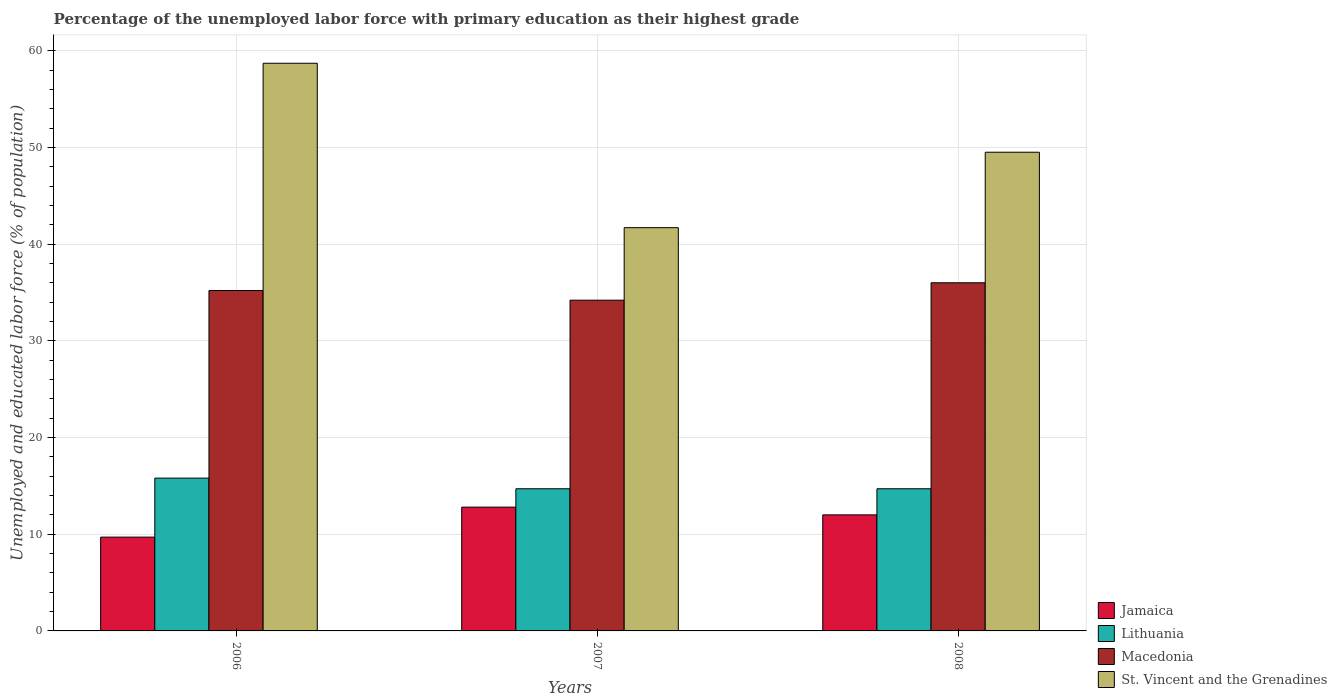Are the number of bars per tick equal to the number of legend labels?
Your response must be concise. Yes. What is the label of the 3rd group of bars from the left?
Ensure brevity in your answer.  2008. Across all years, what is the maximum percentage of the unemployed labor force with primary education in Lithuania?
Give a very brief answer. 15.8. Across all years, what is the minimum percentage of the unemployed labor force with primary education in Lithuania?
Keep it short and to the point. 14.7. What is the total percentage of the unemployed labor force with primary education in Jamaica in the graph?
Keep it short and to the point. 34.5. What is the difference between the percentage of the unemployed labor force with primary education in Lithuania in 2006 and that in 2007?
Give a very brief answer. 1.1. What is the difference between the percentage of the unemployed labor force with primary education in St. Vincent and the Grenadines in 2007 and the percentage of the unemployed labor force with primary education in Jamaica in 2006?
Offer a very short reply. 32. What is the average percentage of the unemployed labor force with primary education in St. Vincent and the Grenadines per year?
Provide a succinct answer. 49.97. In the year 2008, what is the difference between the percentage of the unemployed labor force with primary education in Lithuania and percentage of the unemployed labor force with primary education in St. Vincent and the Grenadines?
Make the answer very short. -34.8. What is the difference between the highest and the second highest percentage of the unemployed labor force with primary education in St. Vincent and the Grenadines?
Provide a succinct answer. 9.2. What is the difference between the highest and the lowest percentage of the unemployed labor force with primary education in Macedonia?
Provide a short and direct response. 1.8. Is the sum of the percentage of the unemployed labor force with primary education in Lithuania in 2007 and 2008 greater than the maximum percentage of the unemployed labor force with primary education in Jamaica across all years?
Your response must be concise. Yes. What does the 4th bar from the left in 2006 represents?
Give a very brief answer. St. Vincent and the Grenadines. What does the 3rd bar from the right in 2006 represents?
Offer a very short reply. Lithuania. What is the difference between two consecutive major ticks on the Y-axis?
Keep it short and to the point. 10. Where does the legend appear in the graph?
Your response must be concise. Bottom right. How many legend labels are there?
Provide a succinct answer. 4. How are the legend labels stacked?
Keep it short and to the point. Vertical. What is the title of the graph?
Offer a terse response. Percentage of the unemployed labor force with primary education as their highest grade. Does "Gabon" appear as one of the legend labels in the graph?
Make the answer very short. No. What is the label or title of the Y-axis?
Keep it short and to the point. Unemployed and educated labor force (% of population). What is the Unemployed and educated labor force (% of population) in Jamaica in 2006?
Your answer should be very brief. 9.7. What is the Unemployed and educated labor force (% of population) in Lithuania in 2006?
Provide a short and direct response. 15.8. What is the Unemployed and educated labor force (% of population) of Macedonia in 2006?
Make the answer very short. 35.2. What is the Unemployed and educated labor force (% of population) of St. Vincent and the Grenadines in 2006?
Ensure brevity in your answer.  58.7. What is the Unemployed and educated labor force (% of population) in Jamaica in 2007?
Your answer should be very brief. 12.8. What is the Unemployed and educated labor force (% of population) in Lithuania in 2007?
Your answer should be very brief. 14.7. What is the Unemployed and educated labor force (% of population) of Macedonia in 2007?
Ensure brevity in your answer.  34.2. What is the Unemployed and educated labor force (% of population) of St. Vincent and the Grenadines in 2007?
Provide a succinct answer. 41.7. What is the Unemployed and educated labor force (% of population) in Jamaica in 2008?
Your answer should be very brief. 12. What is the Unemployed and educated labor force (% of population) of Lithuania in 2008?
Ensure brevity in your answer.  14.7. What is the Unemployed and educated labor force (% of population) of Macedonia in 2008?
Provide a succinct answer. 36. What is the Unemployed and educated labor force (% of population) in St. Vincent and the Grenadines in 2008?
Provide a short and direct response. 49.5. Across all years, what is the maximum Unemployed and educated labor force (% of population) in Jamaica?
Your answer should be compact. 12.8. Across all years, what is the maximum Unemployed and educated labor force (% of population) in Lithuania?
Offer a terse response. 15.8. Across all years, what is the maximum Unemployed and educated labor force (% of population) in St. Vincent and the Grenadines?
Ensure brevity in your answer.  58.7. Across all years, what is the minimum Unemployed and educated labor force (% of population) of Jamaica?
Offer a terse response. 9.7. Across all years, what is the minimum Unemployed and educated labor force (% of population) of Lithuania?
Your answer should be compact. 14.7. Across all years, what is the minimum Unemployed and educated labor force (% of population) in Macedonia?
Ensure brevity in your answer.  34.2. Across all years, what is the minimum Unemployed and educated labor force (% of population) of St. Vincent and the Grenadines?
Your answer should be compact. 41.7. What is the total Unemployed and educated labor force (% of population) of Jamaica in the graph?
Your answer should be compact. 34.5. What is the total Unemployed and educated labor force (% of population) of Lithuania in the graph?
Offer a very short reply. 45.2. What is the total Unemployed and educated labor force (% of population) in Macedonia in the graph?
Provide a succinct answer. 105.4. What is the total Unemployed and educated labor force (% of population) of St. Vincent and the Grenadines in the graph?
Give a very brief answer. 149.9. What is the difference between the Unemployed and educated labor force (% of population) of Macedonia in 2006 and that in 2007?
Your answer should be very brief. 1. What is the difference between the Unemployed and educated labor force (% of population) of Jamaica in 2006 and that in 2008?
Ensure brevity in your answer.  -2.3. What is the difference between the Unemployed and educated labor force (% of population) in Lithuania in 2006 and that in 2008?
Your response must be concise. 1.1. What is the difference between the Unemployed and educated labor force (% of population) of Macedonia in 2006 and that in 2008?
Your response must be concise. -0.8. What is the difference between the Unemployed and educated labor force (% of population) in St. Vincent and the Grenadines in 2006 and that in 2008?
Your answer should be very brief. 9.2. What is the difference between the Unemployed and educated labor force (% of population) of Jamaica in 2007 and that in 2008?
Offer a very short reply. 0.8. What is the difference between the Unemployed and educated labor force (% of population) in Lithuania in 2007 and that in 2008?
Ensure brevity in your answer.  0. What is the difference between the Unemployed and educated labor force (% of population) in St. Vincent and the Grenadines in 2007 and that in 2008?
Give a very brief answer. -7.8. What is the difference between the Unemployed and educated labor force (% of population) in Jamaica in 2006 and the Unemployed and educated labor force (% of population) in Macedonia in 2007?
Your answer should be very brief. -24.5. What is the difference between the Unemployed and educated labor force (% of population) in Jamaica in 2006 and the Unemployed and educated labor force (% of population) in St. Vincent and the Grenadines in 2007?
Keep it short and to the point. -32. What is the difference between the Unemployed and educated labor force (% of population) in Lithuania in 2006 and the Unemployed and educated labor force (% of population) in Macedonia in 2007?
Ensure brevity in your answer.  -18.4. What is the difference between the Unemployed and educated labor force (% of population) of Lithuania in 2006 and the Unemployed and educated labor force (% of population) of St. Vincent and the Grenadines in 2007?
Offer a terse response. -25.9. What is the difference between the Unemployed and educated labor force (% of population) of Jamaica in 2006 and the Unemployed and educated labor force (% of population) of Lithuania in 2008?
Your answer should be very brief. -5. What is the difference between the Unemployed and educated labor force (% of population) of Jamaica in 2006 and the Unemployed and educated labor force (% of population) of Macedonia in 2008?
Offer a very short reply. -26.3. What is the difference between the Unemployed and educated labor force (% of population) in Jamaica in 2006 and the Unemployed and educated labor force (% of population) in St. Vincent and the Grenadines in 2008?
Provide a succinct answer. -39.8. What is the difference between the Unemployed and educated labor force (% of population) of Lithuania in 2006 and the Unemployed and educated labor force (% of population) of Macedonia in 2008?
Make the answer very short. -20.2. What is the difference between the Unemployed and educated labor force (% of population) of Lithuania in 2006 and the Unemployed and educated labor force (% of population) of St. Vincent and the Grenadines in 2008?
Offer a very short reply. -33.7. What is the difference between the Unemployed and educated labor force (% of population) of Macedonia in 2006 and the Unemployed and educated labor force (% of population) of St. Vincent and the Grenadines in 2008?
Ensure brevity in your answer.  -14.3. What is the difference between the Unemployed and educated labor force (% of population) in Jamaica in 2007 and the Unemployed and educated labor force (% of population) in Macedonia in 2008?
Give a very brief answer. -23.2. What is the difference between the Unemployed and educated labor force (% of population) of Jamaica in 2007 and the Unemployed and educated labor force (% of population) of St. Vincent and the Grenadines in 2008?
Offer a very short reply. -36.7. What is the difference between the Unemployed and educated labor force (% of population) in Lithuania in 2007 and the Unemployed and educated labor force (% of population) in Macedonia in 2008?
Make the answer very short. -21.3. What is the difference between the Unemployed and educated labor force (% of population) of Lithuania in 2007 and the Unemployed and educated labor force (% of population) of St. Vincent and the Grenadines in 2008?
Provide a succinct answer. -34.8. What is the difference between the Unemployed and educated labor force (% of population) in Macedonia in 2007 and the Unemployed and educated labor force (% of population) in St. Vincent and the Grenadines in 2008?
Offer a very short reply. -15.3. What is the average Unemployed and educated labor force (% of population) in Lithuania per year?
Make the answer very short. 15.07. What is the average Unemployed and educated labor force (% of population) in Macedonia per year?
Make the answer very short. 35.13. What is the average Unemployed and educated labor force (% of population) in St. Vincent and the Grenadines per year?
Offer a terse response. 49.97. In the year 2006, what is the difference between the Unemployed and educated labor force (% of population) of Jamaica and Unemployed and educated labor force (% of population) of Macedonia?
Your answer should be very brief. -25.5. In the year 2006, what is the difference between the Unemployed and educated labor force (% of population) of Jamaica and Unemployed and educated labor force (% of population) of St. Vincent and the Grenadines?
Make the answer very short. -49. In the year 2006, what is the difference between the Unemployed and educated labor force (% of population) of Lithuania and Unemployed and educated labor force (% of population) of Macedonia?
Your answer should be compact. -19.4. In the year 2006, what is the difference between the Unemployed and educated labor force (% of population) in Lithuania and Unemployed and educated labor force (% of population) in St. Vincent and the Grenadines?
Your answer should be compact. -42.9. In the year 2006, what is the difference between the Unemployed and educated labor force (% of population) of Macedonia and Unemployed and educated labor force (% of population) of St. Vincent and the Grenadines?
Keep it short and to the point. -23.5. In the year 2007, what is the difference between the Unemployed and educated labor force (% of population) in Jamaica and Unemployed and educated labor force (% of population) in Macedonia?
Your answer should be very brief. -21.4. In the year 2007, what is the difference between the Unemployed and educated labor force (% of population) of Jamaica and Unemployed and educated labor force (% of population) of St. Vincent and the Grenadines?
Ensure brevity in your answer.  -28.9. In the year 2007, what is the difference between the Unemployed and educated labor force (% of population) in Lithuania and Unemployed and educated labor force (% of population) in Macedonia?
Make the answer very short. -19.5. In the year 2007, what is the difference between the Unemployed and educated labor force (% of population) in Macedonia and Unemployed and educated labor force (% of population) in St. Vincent and the Grenadines?
Your answer should be very brief. -7.5. In the year 2008, what is the difference between the Unemployed and educated labor force (% of population) in Jamaica and Unemployed and educated labor force (% of population) in Lithuania?
Your answer should be very brief. -2.7. In the year 2008, what is the difference between the Unemployed and educated labor force (% of population) of Jamaica and Unemployed and educated labor force (% of population) of Macedonia?
Your answer should be very brief. -24. In the year 2008, what is the difference between the Unemployed and educated labor force (% of population) in Jamaica and Unemployed and educated labor force (% of population) in St. Vincent and the Grenadines?
Keep it short and to the point. -37.5. In the year 2008, what is the difference between the Unemployed and educated labor force (% of population) in Lithuania and Unemployed and educated labor force (% of population) in Macedonia?
Offer a very short reply. -21.3. In the year 2008, what is the difference between the Unemployed and educated labor force (% of population) of Lithuania and Unemployed and educated labor force (% of population) of St. Vincent and the Grenadines?
Give a very brief answer. -34.8. What is the ratio of the Unemployed and educated labor force (% of population) of Jamaica in 2006 to that in 2007?
Give a very brief answer. 0.76. What is the ratio of the Unemployed and educated labor force (% of population) in Lithuania in 2006 to that in 2007?
Your response must be concise. 1.07. What is the ratio of the Unemployed and educated labor force (% of population) in Macedonia in 2006 to that in 2007?
Your answer should be compact. 1.03. What is the ratio of the Unemployed and educated labor force (% of population) in St. Vincent and the Grenadines in 2006 to that in 2007?
Provide a succinct answer. 1.41. What is the ratio of the Unemployed and educated labor force (% of population) of Jamaica in 2006 to that in 2008?
Your answer should be compact. 0.81. What is the ratio of the Unemployed and educated labor force (% of population) of Lithuania in 2006 to that in 2008?
Ensure brevity in your answer.  1.07. What is the ratio of the Unemployed and educated labor force (% of population) in Macedonia in 2006 to that in 2008?
Offer a very short reply. 0.98. What is the ratio of the Unemployed and educated labor force (% of population) of St. Vincent and the Grenadines in 2006 to that in 2008?
Ensure brevity in your answer.  1.19. What is the ratio of the Unemployed and educated labor force (% of population) of Jamaica in 2007 to that in 2008?
Keep it short and to the point. 1.07. What is the ratio of the Unemployed and educated labor force (% of population) of Lithuania in 2007 to that in 2008?
Your answer should be very brief. 1. What is the ratio of the Unemployed and educated labor force (% of population) in Macedonia in 2007 to that in 2008?
Provide a succinct answer. 0.95. What is the ratio of the Unemployed and educated labor force (% of population) in St. Vincent and the Grenadines in 2007 to that in 2008?
Your answer should be compact. 0.84. What is the difference between the highest and the second highest Unemployed and educated labor force (% of population) of Lithuania?
Provide a short and direct response. 1.1. What is the difference between the highest and the lowest Unemployed and educated labor force (% of population) in Jamaica?
Ensure brevity in your answer.  3.1. What is the difference between the highest and the lowest Unemployed and educated labor force (% of population) of Lithuania?
Provide a succinct answer. 1.1. What is the difference between the highest and the lowest Unemployed and educated labor force (% of population) of Macedonia?
Offer a terse response. 1.8. 